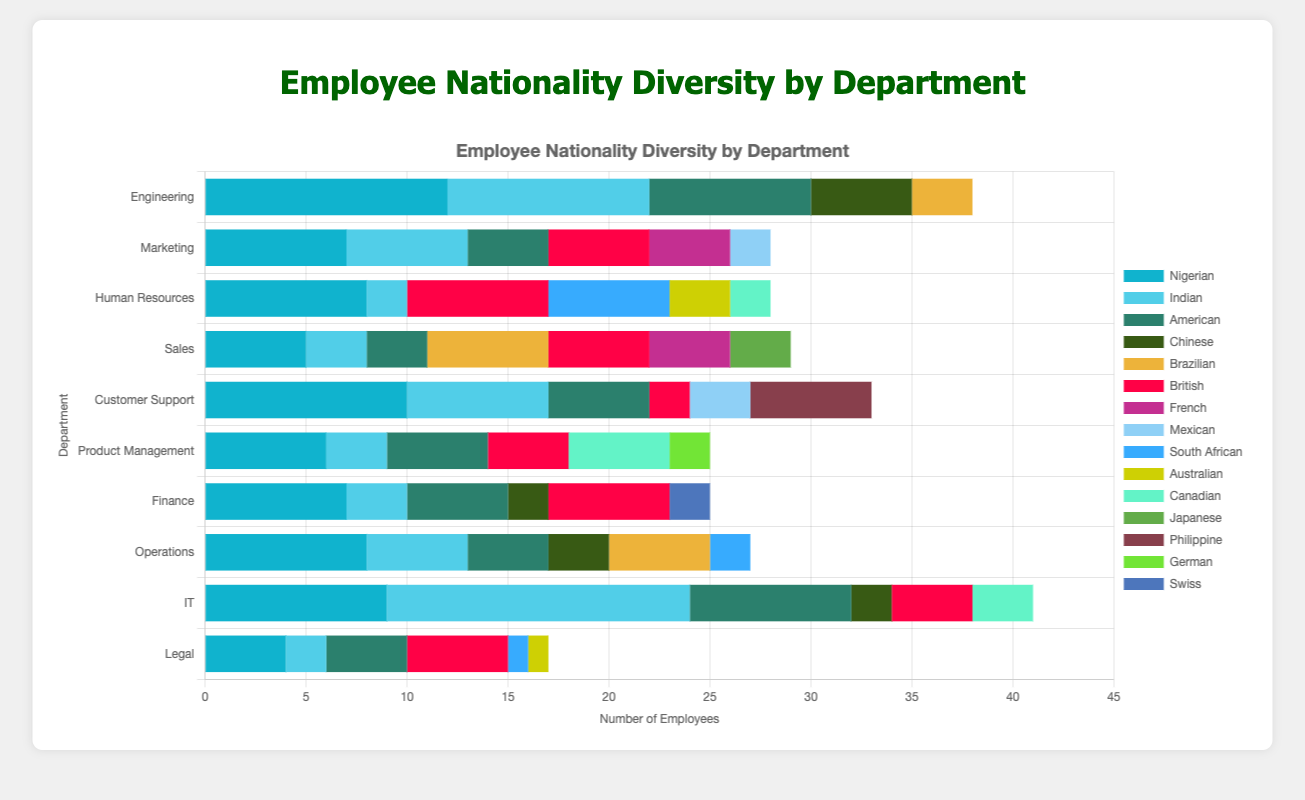1. Which department has the highest number of Nigerian employees? By observing the bar chart, find the department with the longest segment labeled "Nigerian".
Answer: Engineering 2. What is the total number of Indian employees across all departments? Sum the values of Indian employees in each department: 10 (Engineering) + 6 (Marketing) + 2 (Human Resources) + 3 (Sales) + 7 (Customer Support) + 3 (Product Management) + 3 (Finance) + 5 (Operations) + 15 (IT) + 2 (Legal) = 56
Answer: 56 3. How many more Nigerians are there in IT than in Legal? Subtract the number of Nigerian employees in Legal from the number in IT: 9 (IT) - 4 (Legal) = 5
Answer: 5 4. What is the average number of American employees per department? Sum the number of American employees in each department and divide by the total number of departments: (8 + 4 + 0 + 3 + 5 + 5 + 5 + 4 + 8 + 4) / 10 = 4.6
Answer: 4.6 5. Which department has a higher number of Brazilian employees, Sales or Engineering? By observing the respective bar segments for "Brazilian" in Sales and Engineering, compare their lengths. Sales has 6, while Engineering has 3.
Answer: Sales 6. Across all departments, what is the median number of Nigerian employees? Arrange the number of Nigerian employees in ascending order and find the middle number: [4, 5, 6, 7, 7, 8, 8, 9, 10, 12]. The median is the average of the 5th and 6th values: (7 + 8) / 2 = 7.5
Answer: 7.5 7. What is the difference between the number of British employees in Marketing and in Human Resources? Subtract the number of British employees in Human Resources from those in Marketing: 5 (Marketing) - 7 (Human Resources) = -2
Answer: -2 8. Which department has the shortest bar segment for South African employees? Find the bar segment labeled "South African" and identify the department with the smallest value. Legal and Operations both show values of 1 and 2 respectively.
Answer: Legal 9. How many Canadian employees are there in total in Product Management and IT? Sum the values of Canadian employees in Product Management and IT: 5 (Product Management) + 3 (IT) = 8
Answer: 8 10. Which nationality is most represented in the Customer Support department? By observing the longest bar segment in the Customer Support department, "Nigerian" has the highest value of 10.
Answer: Nigerian 